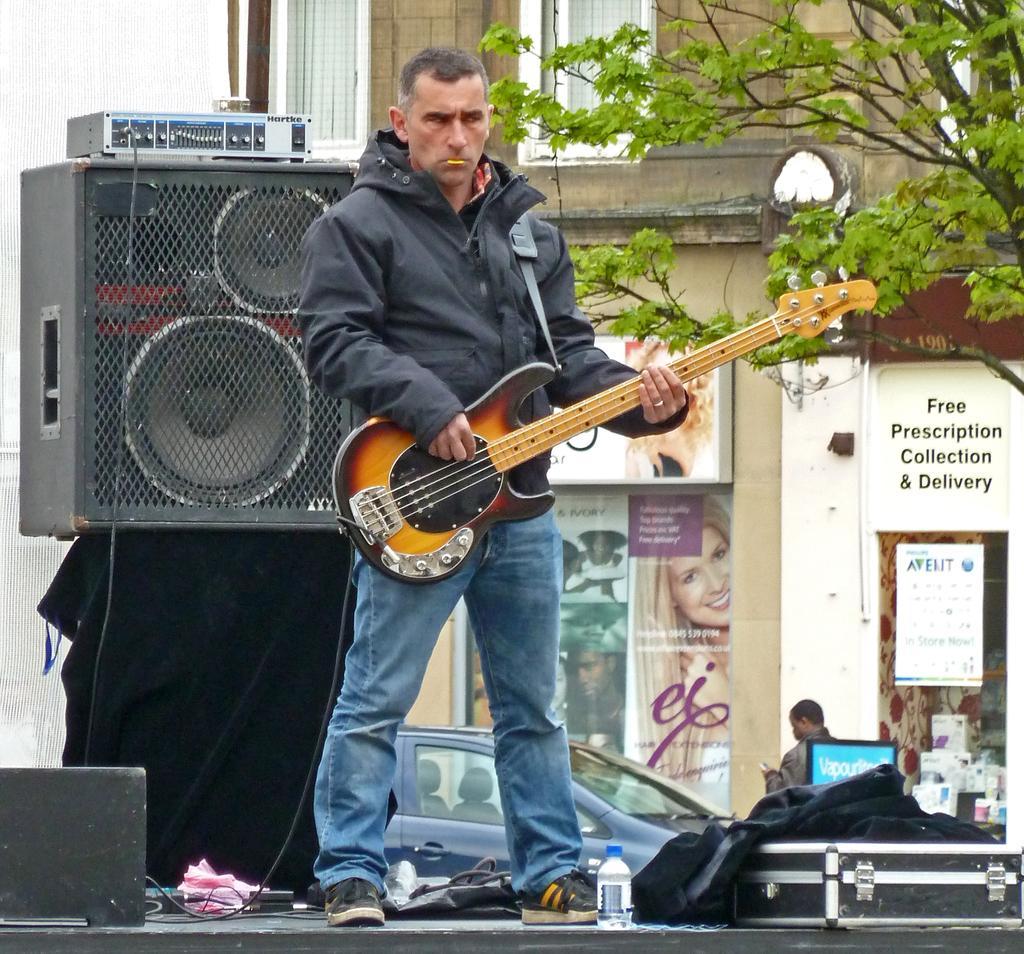Describe this image in one or two sentences. Here in the middle we can see a man playing guitar and behind him we can see speakers there is a building, there is a tree and posters and cars present 